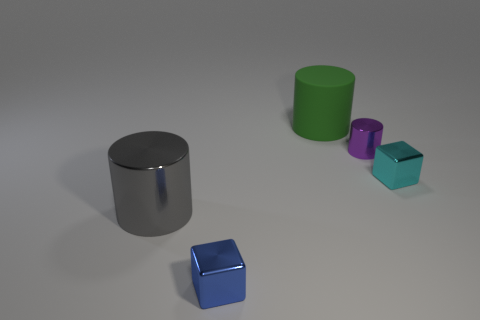Add 2 tiny red metal things. How many objects exist? 7 Subtract all cubes. How many objects are left? 3 Add 2 tiny yellow matte spheres. How many tiny yellow matte spheres exist? 2 Subtract 0 yellow balls. How many objects are left? 5 Subtract all blue shiny objects. Subtract all gray metallic cylinders. How many objects are left? 3 Add 4 cubes. How many cubes are left? 6 